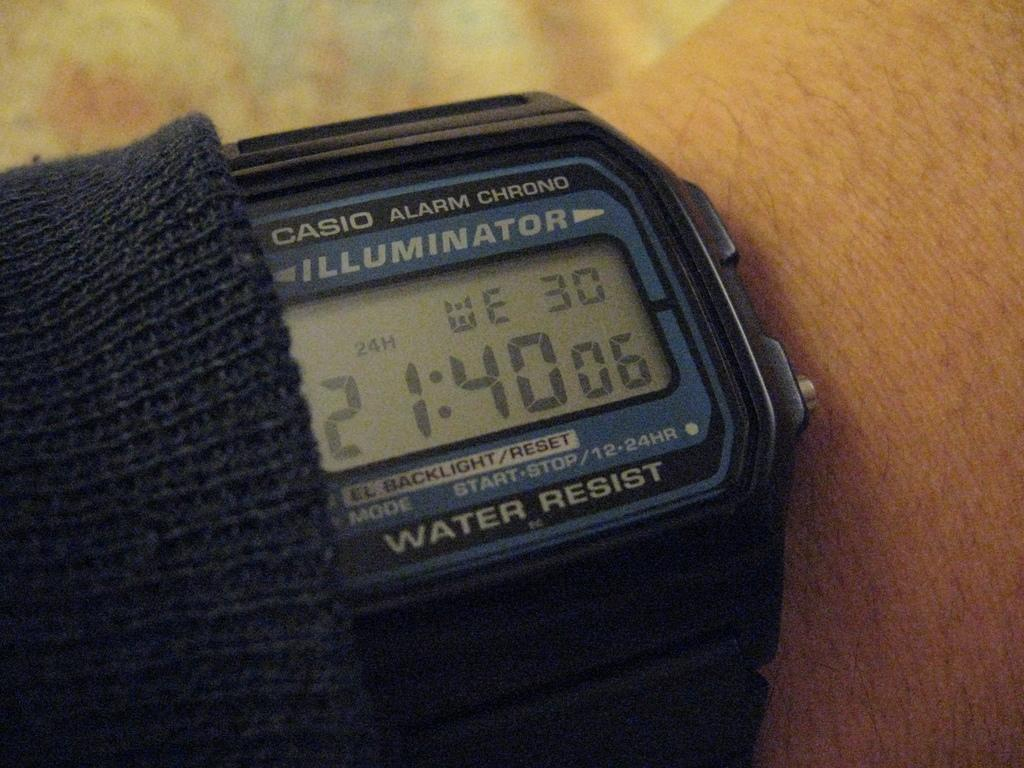<image>
Present a compact description of the photo's key features. Person wearing a blue and black watch that says Water Resist. 